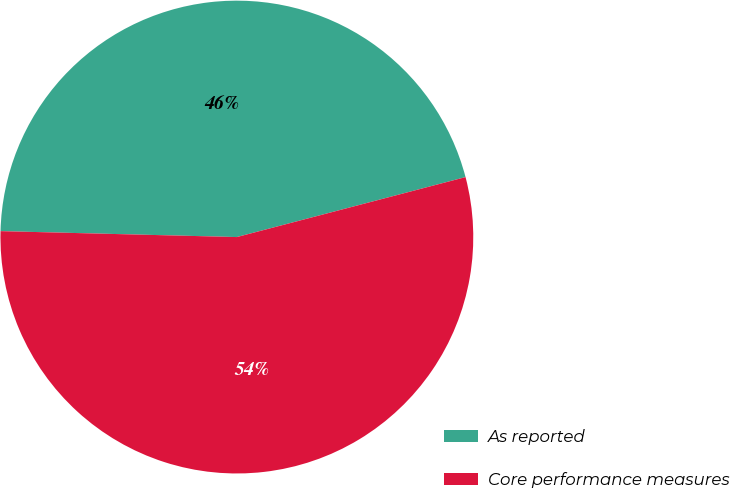Convert chart. <chart><loc_0><loc_0><loc_500><loc_500><pie_chart><fcel>As reported<fcel>Core performance measures<nl><fcel>45.52%<fcel>54.48%<nl></chart> 